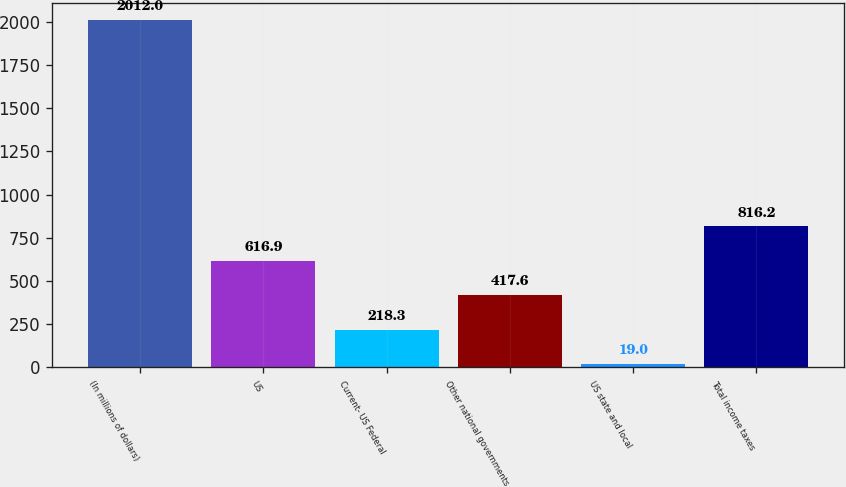Convert chart. <chart><loc_0><loc_0><loc_500><loc_500><bar_chart><fcel>(In millions of dollars)<fcel>US<fcel>Current- US Federal<fcel>Other national governments<fcel>US state and local<fcel>Total income taxes<nl><fcel>2012<fcel>616.9<fcel>218.3<fcel>417.6<fcel>19<fcel>816.2<nl></chart> 